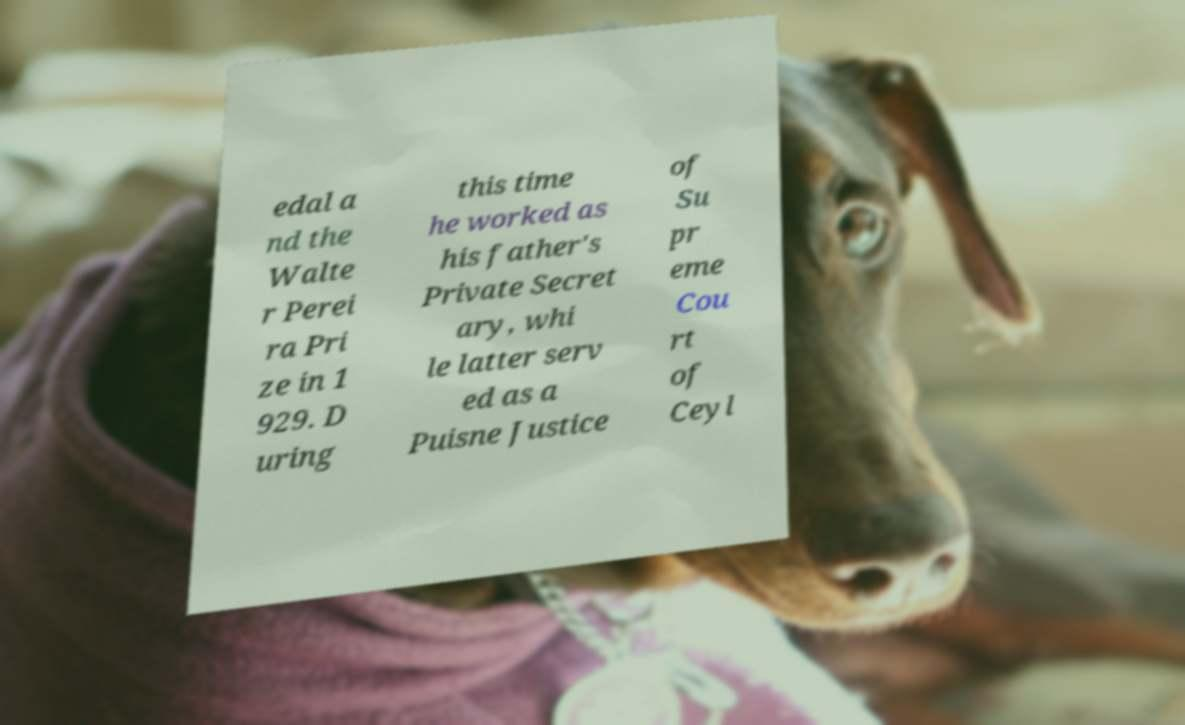Can you accurately transcribe the text from the provided image for me? edal a nd the Walte r Perei ra Pri ze in 1 929. D uring this time he worked as his father's Private Secret ary, whi le latter serv ed as a Puisne Justice of Su pr eme Cou rt of Ceyl 